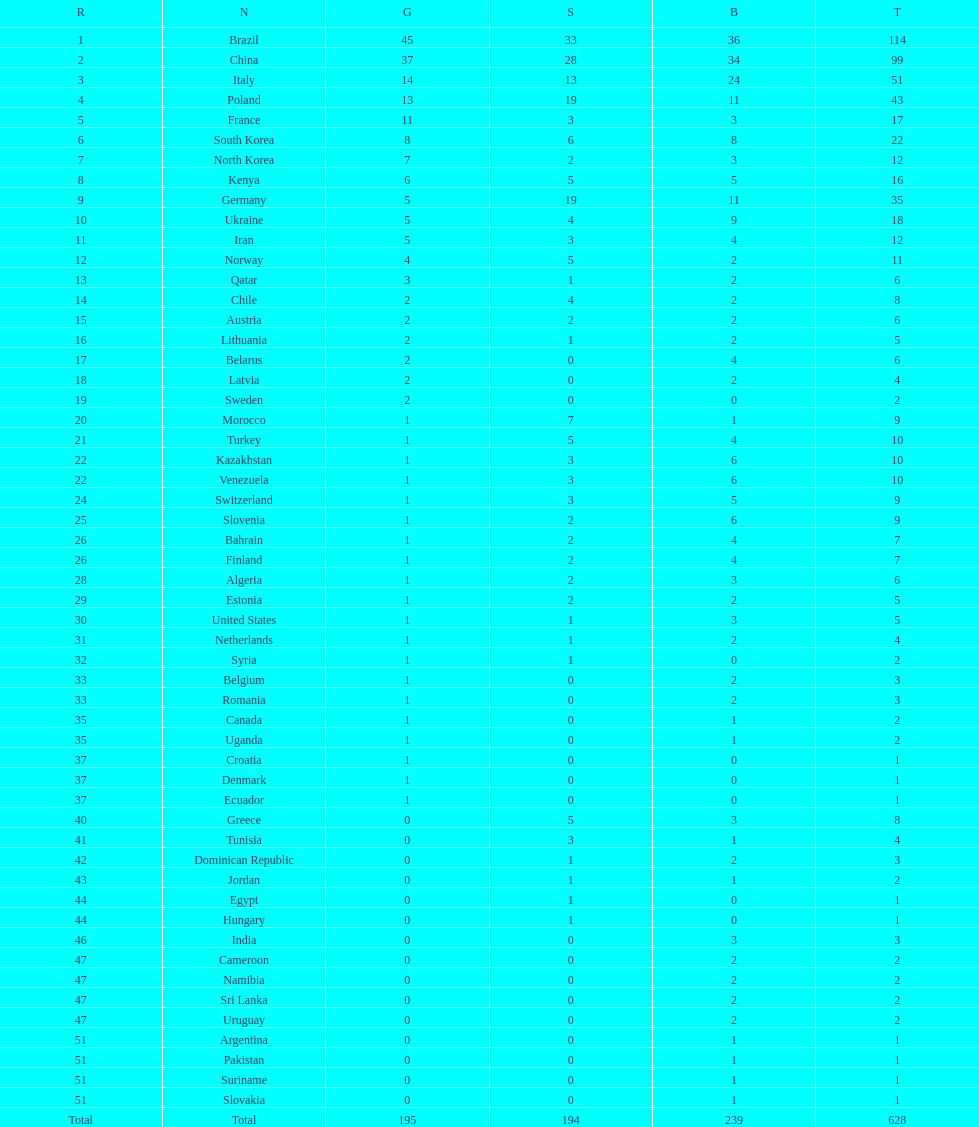What is the total number of medals between south korea, north korea, sweden, and brazil? 150. Would you be able to parse every entry in this table? {'header': ['R', 'N', 'G', 'S', 'B', 'T'], 'rows': [['1', 'Brazil', '45', '33', '36', '114'], ['2', 'China', '37', '28', '34', '99'], ['3', 'Italy', '14', '13', '24', '51'], ['4', 'Poland', '13', '19', '11', '43'], ['5', 'France', '11', '3', '3', '17'], ['6', 'South Korea', '8', '6', '8', '22'], ['7', 'North Korea', '7', '2', '3', '12'], ['8', 'Kenya', '6', '5', '5', '16'], ['9', 'Germany', '5', '19', '11', '35'], ['10', 'Ukraine', '5', '4', '9', '18'], ['11', 'Iran', '5', '3', '4', '12'], ['12', 'Norway', '4', '5', '2', '11'], ['13', 'Qatar', '3', '1', '2', '6'], ['14', 'Chile', '2', '4', '2', '8'], ['15', 'Austria', '2', '2', '2', '6'], ['16', 'Lithuania', '2', '1', '2', '5'], ['17', 'Belarus', '2', '0', '4', '6'], ['18', 'Latvia', '2', '0', '2', '4'], ['19', 'Sweden', '2', '0', '0', '2'], ['20', 'Morocco', '1', '7', '1', '9'], ['21', 'Turkey', '1', '5', '4', '10'], ['22', 'Kazakhstan', '1', '3', '6', '10'], ['22', 'Venezuela', '1', '3', '6', '10'], ['24', 'Switzerland', '1', '3', '5', '9'], ['25', 'Slovenia', '1', '2', '6', '9'], ['26', 'Bahrain', '1', '2', '4', '7'], ['26', 'Finland', '1', '2', '4', '7'], ['28', 'Algeria', '1', '2', '3', '6'], ['29', 'Estonia', '1', '2', '2', '5'], ['30', 'United States', '1', '1', '3', '5'], ['31', 'Netherlands', '1', '1', '2', '4'], ['32', 'Syria', '1', '1', '0', '2'], ['33', 'Belgium', '1', '0', '2', '3'], ['33', 'Romania', '1', '0', '2', '3'], ['35', 'Canada', '1', '0', '1', '2'], ['35', 'Uganda', '1', '0', '1', '2'], ['37', 'Croatia', '1', '0', '0', '1'], ['37', 'Denmark', '1', '0', '0', '1'], ['37', 'Ecuador', '1', '0', '0', '1'], ['40', 'Greece', '0', '5', '3', '8'], ['41', 'Tunisia', '0', '3', '1', '4'], ['42', 'Dominican Republic', '0', '1', '2', '3'], ['43', 'Jordan', '0', '1', '1', '2'], ['44', 'Egypt', '0', '1', '0', '1'], ['44', 'Hungary', '0', '1', '0', '1'], ['46', 'India', '0', '0', '3', '3'], ['47', 'Cameroon', '0', '0', '2', '2'], ['47', 'Namibia', '0', '0', '2', '2'], ['47', 'Sri Lanka', '0', '0', '2', '2'], ['47', 'Uruguay', '0', '0', '2', '2'], ['51', 'Argentina', '0', '0', '1', '1'], ['51', 'Pakistan', '0', '0', '1', '1'], ['51', 'Suriname', '0', '0', '1', '1'], ['51', 'Slovakia', '0', '0', '1', '1'], ['Total', 'Total', '195', '194', '239', '628']]} 